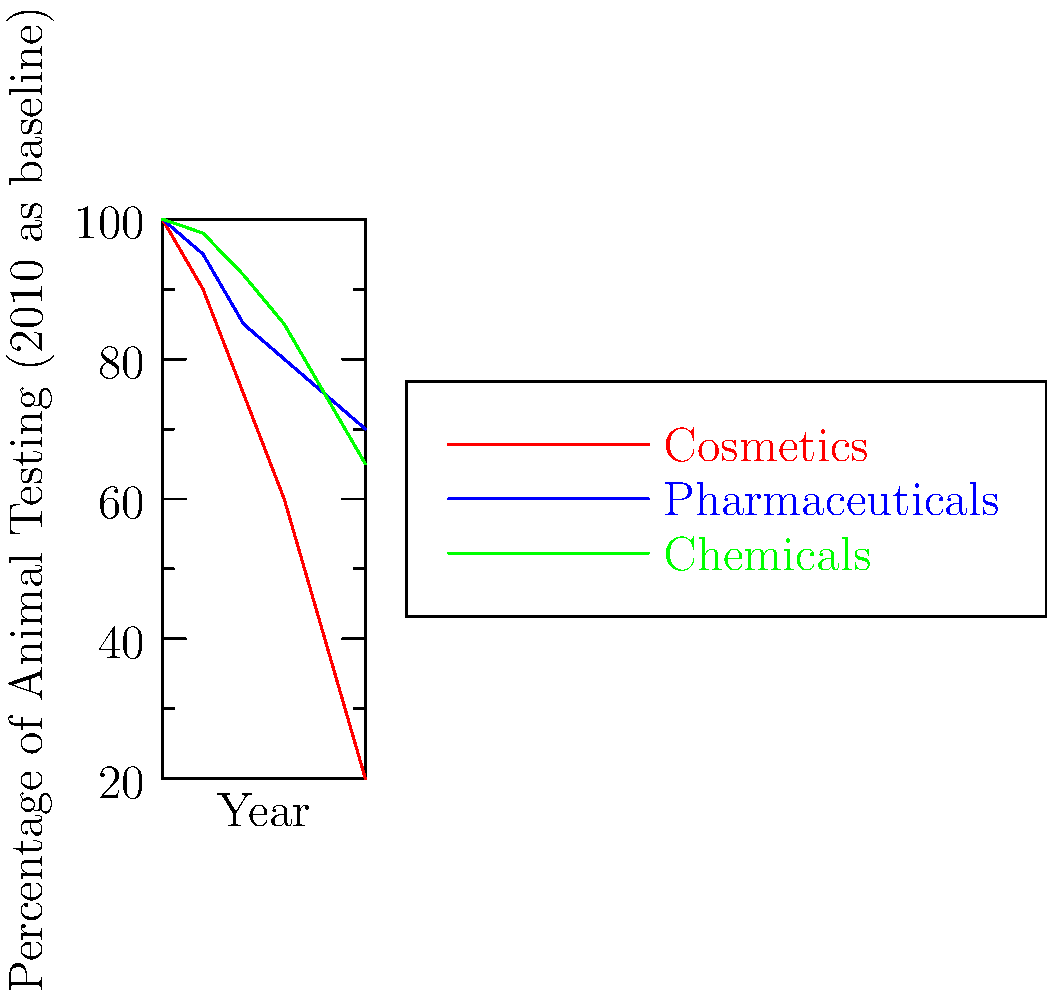The graph shows the decline in animal testing across three industries from 2010 to 2020. Which industry demonstrated the most significant reduction in animal testing by 2020, and what percentage decrease did it achieve compared to its 2010 baseline? To answer this question, we need to follow these steps:

1. Identify the three industries represented in the graph:
   - Cosmetics (red line)
   - Pharmaceuticals (blue line)
   - Chemicals (green line)

2. Observe the starting point (2010) and endpoint (2020) for each industry:
   - Cosmetics: Starts at 100% in 2010, ends at 20% in 2020
   - Pharmaceuticals: Starts at 100% in 2010, ends at 70% in 2020
   - Chemicals: Starts at 100% in 2010, ends at 65% in 2020

3. Calculate the percentage decrease for each industry:
   - Cosmetics: 100% - 20% = 80% decrease
   - Pharmaceuticals: 100% - 70% = 30% decrease
   - Chemicals: 100% - 65% = 35% decrease

4. Identify the industry with the largest decrease:
   Cosmetics shows the most significant reduction at 80%.

Therefore, the cosmetics industry demonstrated the most significant reduction in animal testing by 2020, with an 80% decrease compared to its 2010 baseline.
Answer: Cosmetics industry, 80% decrease 